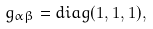Convert formula to latex. <formula><loc_0><loc_0><loc_500><loc_500>g _ { \alpha \beta } = d i a g ( 1 , 1 , 1 ) ,</formula> 